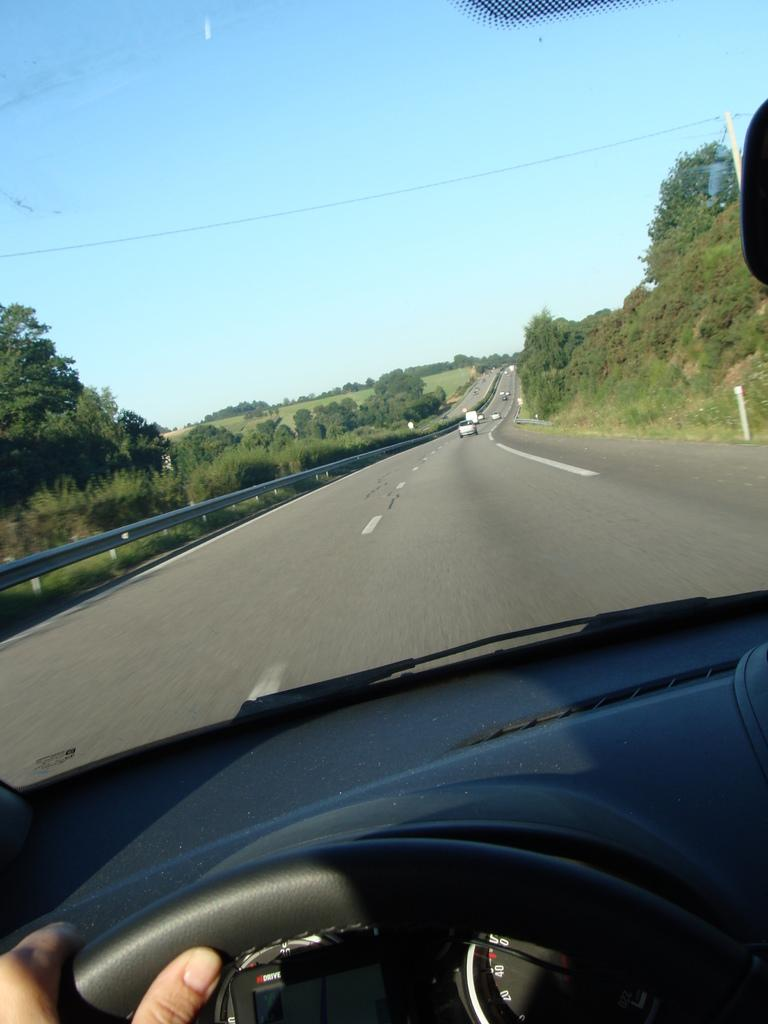What is happening inside the car in the image? There is a person inside the car, and their hand is on the steering wheel. What can be seen through the front glass door of the car? Vehicles on the road, a fence, a pole, trees, grass, and the sky are visible through the front glass door. How many different elements can be seen through the front glass door? There are eight different elements visible through the front glass door. Where are the chickens located in the image? There are no chickens present in the image. How quiet is the environment in the image? The image does not provide any information about the noise level or quietness of the environment. 